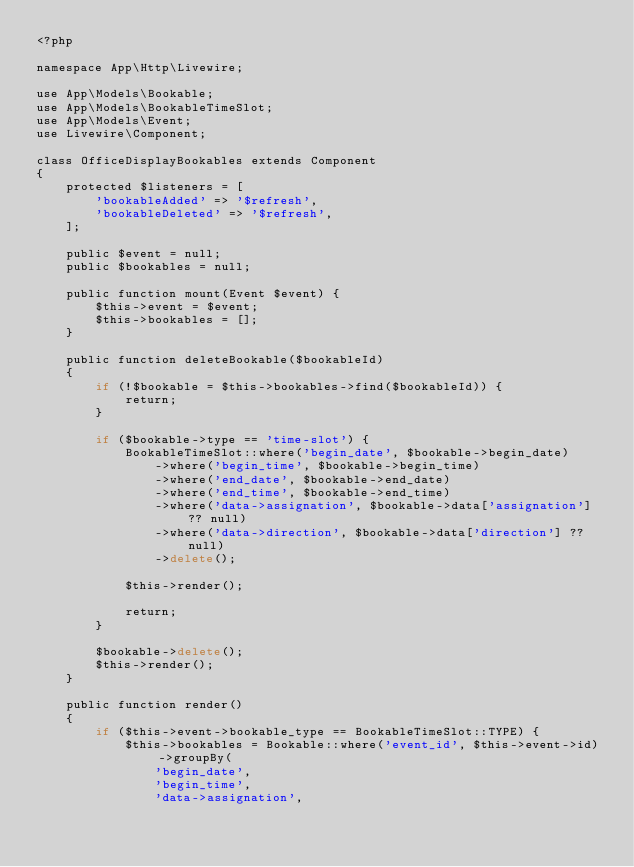<code> <loc_0><loc_0><loc_500><loc_500><_PHP_><?php

namespace App\Http\Livewire;

use App\Models\Bookable;
use App\Models\BookableTimeSlot;
use App\Models\Event;
use Livewire\Component;

class OfficeDisplayBookables extends Component
{
    protected $listeners = [
        'bookableAdded' => '$refresh',
        'bookableDeleted' => '$refresh',
    ];

    public $event = null;
    public $bookables = null;

    public function mount(Event $event) {
        $this->event = $event;
        $this->bookables = [];
    }

    public function deleteBookable($bookableId)
    {
        if (!$bookable = $this->bookables->find($bookableId)) {
            return;
        }

        if ($bookable->type == 'time-slot') {
            BookableTimeSlot::where('begin_date', $bookable->begin_date)
                ->where('begin_time', $bookable->begin_time)
                ->where('end_date', $bookable->end_date)
                ->where('end_time', $bookable->end_time)
                ->where('data->assignation', $bookable->data['assignation'] ?? null)
                ->where('data->direction', $bookable->data['direction'] ?? null)
                ->delete();

            $this->render();

            return;
        }

        $bookable->delete();
        $this->render();
    }

    public function render()
    {
        if ($this->event->bookable_type == BookableTimeSlot::TYPE) {
            $this->bookables = Bookable::where('event_id', $this->event->id)->groupBy(
                'begin_date',
                'begin_time',
                'data->assignation',</code> 